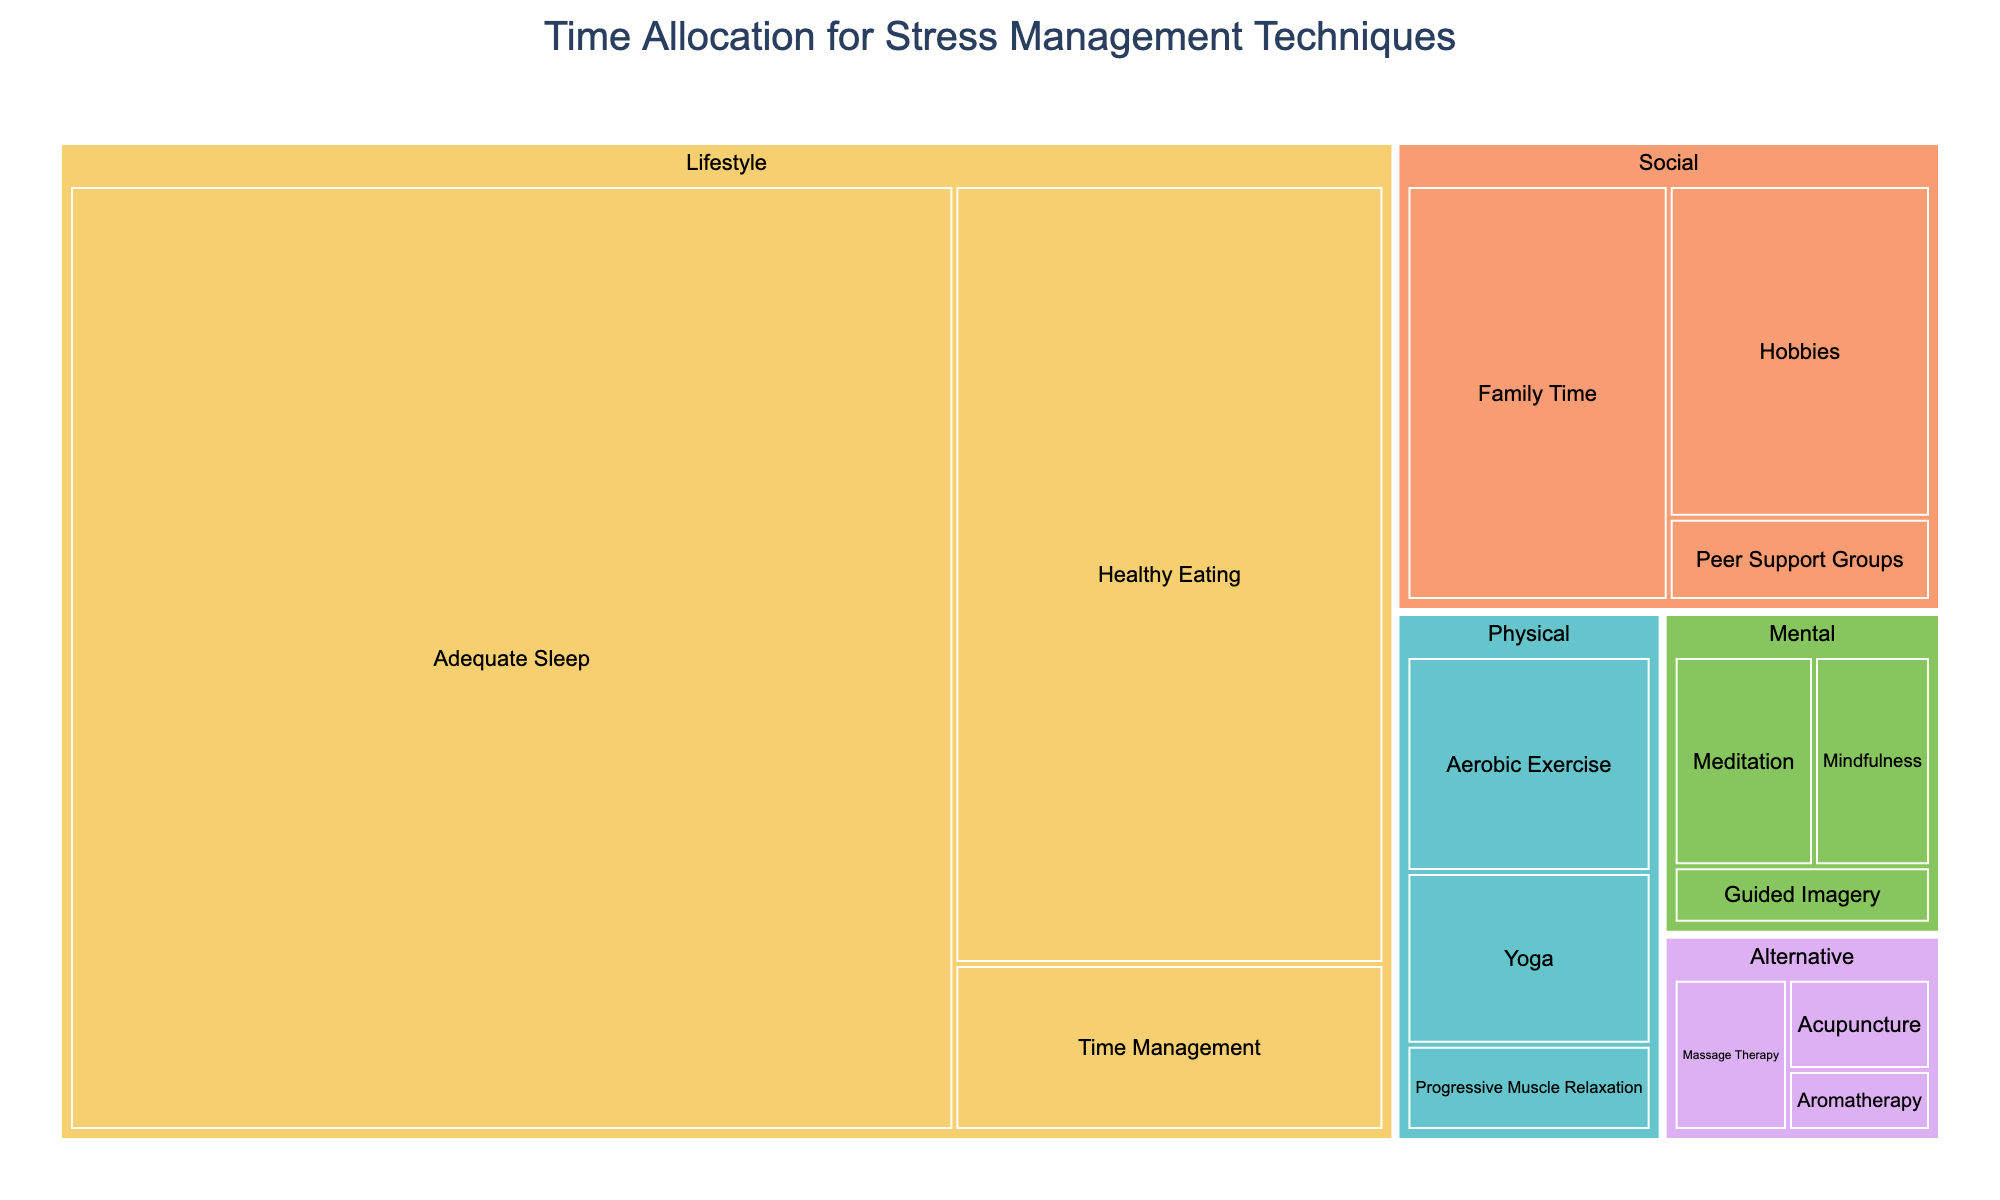What's the title of the figure? The title is usually displayed at the top of the figure, often in a larger or bold font to make it prominent. In this case, the title is "Time Allocation for Stress Management Techniques" as specified in the code.
Answer: Time Allocation for Stress Management Techniques Which stress management technique takes the most time per week? By observing the sizes and labels of the segments, the largest segment indicates the technique with the highest time allocation. The segment for "Adequate Sleep" is the largest and has the value 2100 minutes per week.
Answer: Adequate Sleep What is the total time allocated per week for Physical techniques? To compute the total time for the Physical category, sum the times for all techniques under Physical: Yoga (120 minutes), Progressive Muscle Relaxation (60 minutes), and Aerobic Exercise (150 minutes). So, 120 + 60 + 150 = 330 minutes per week.
Answer: 330 minutes Which category has the smallest total time allocation, and what is it? To find this, compare the sum of times for each category. Alternative has the smallest total, with Acupuncture (45), Aromatherapy (30), and Massage Therapy (60), adding up to 45 + 30 + 60 = 135 minutes per week.
Answer: Alternative, 135 minutes How does the time allocated for Family Time compare to that for Yoga? Locate the segments for Family Time and Yoga. Family Time has 300 minutes and Yoga has 120 minutes. Thus, Family Time has more time allocated compared to Yoga.
Answer: Family Time has more time allocated than Yoga What is the average time allocated per week for Mental techniques? Sum the times for all Mental techniques: Meditation (90), Mindfulness (75), and Guided Imagery (45), giving a total of 90 + 75 + 45 = 210 minutes. Then, divide by the number of techniques (3): 210 / 3 = 70 minutes per week.
Answer: 70 minutes per week Which Social technique has the most time allocated and how much? By checking the segments under the Social category, the segment for Family Time is the largest, with a time allocation of 300 minutes per week.
Answer: Family Time, 300 minutes What is the difference in time allocated between Aerobic Exercise and Hobbies? Locate the segments for Aerobic Exercise (150 minutes) and Hobbies (240 minutes). Calculate the difference: 240 - 150 = 90 minutes.
Answer: 90 minutes How much total time is allocated for Alternative techniques? Sum the times for Acupuncture (45), Aromatherapy (30), and Massage Therapy (60): 45 + 30 + 60 = 135 minutes per week.
Answer: 135 minutes What percentage of total time is spent on Healthy Eating per week? First, find the total time for all techniques, then calculate the percentage for Healthy Eating (840 minutes). Total time is 120+60+150+90+75+45+2100+840+180+60+300+240+45+30+60 = 4345 minutes. Percentage = (840 / 4345) * 100 ≈ 19.33%.
Answer: ≈19.33% 